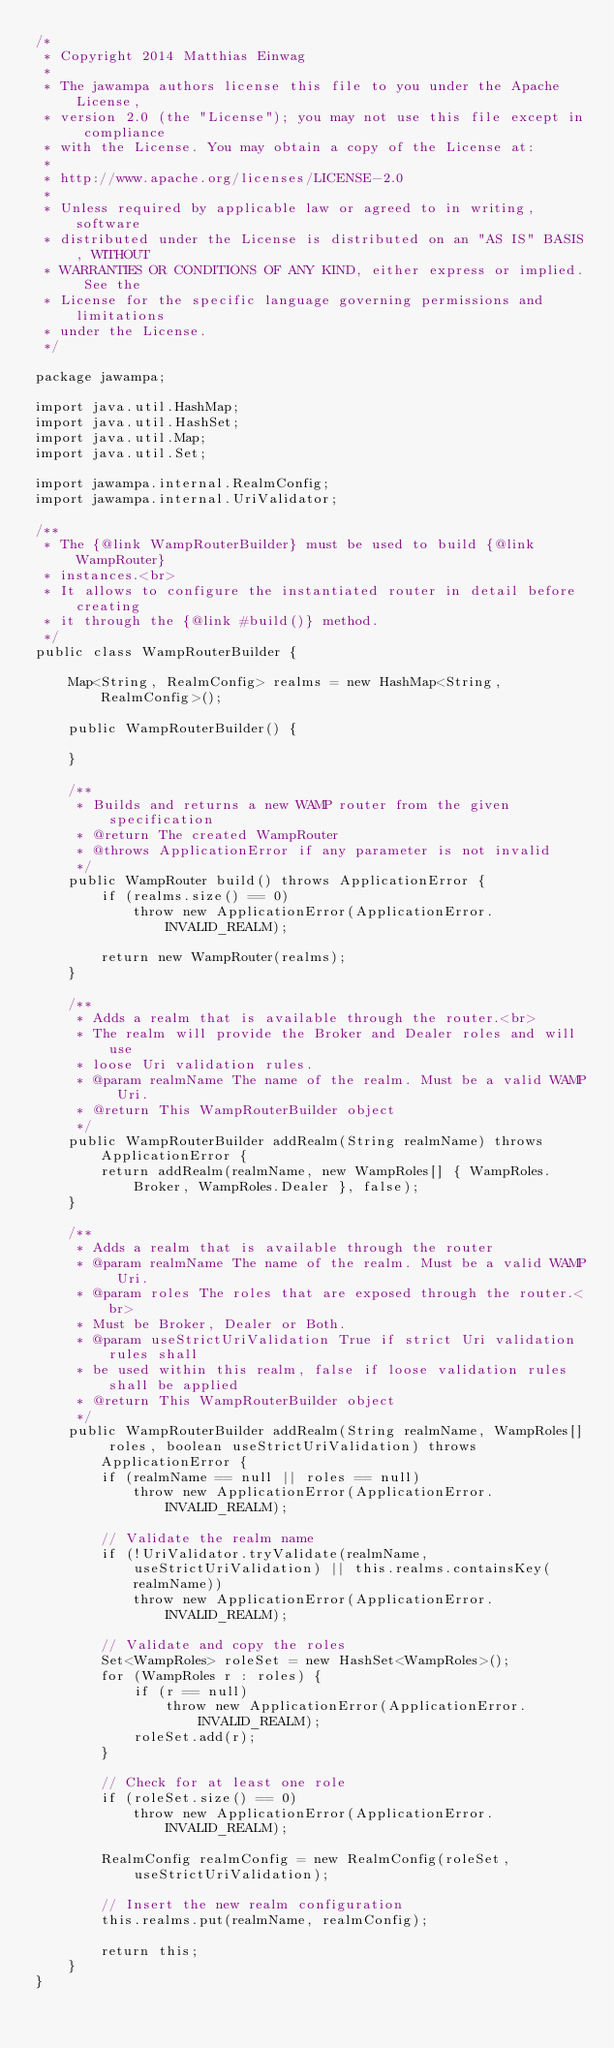<code> <loc_0><loc_0><loc_500><loc_500><_Java_>/*
 * Copyright 2014 Matthias Einwag
 *
 * The jawampa authors license this file to you under the Apache License,
 * version 2.0 (the "License"); you may not use this file except in compliance
 * with the License. You may obtain a copy of the License at:
 *
 * http://www.apache.org/licenses/LICENSE-2.0
 *
 * Unless required by applicable law or agreed to in writing, software
 * distributed under the License is distributed on an "AS IS" BASIS, WITHOUT
 * WARRANTIES OR CONDITIONS OF ANY KIND, either express or implied. See the
 * License for the specific language governing permissions and limitations
 * under the License.
 */

package jawampa;

import java.util.HashMap;
import java.util.HashSet;
import java.util.Map;
import java.util.Set;

import jawampa.internal.RealmConfig;
import jawampa.internal.UriValidator;

/**
 * The {@link WampRouterBuilder} must be used to build {@link WampRouter}
 * instances.<br>
 * It allows to configure the instantiated router in detail before creating
 * it through the {@link #build()} method.
 */
public class WampRouterBuilder {
    
    Map<String, RealmConfig> realms = new HashMap<String, RealmConfig>();

    public WampRouterBuilder() {
        
    }
    
    /**
     * Builds and returns a new WAMP router from the given specification
     * @return The created WampRouter
     * @throws ApplicationError if any parameter is not invalid
     */
    public WampRouter build() throws ApplicationError {
        if (realms.size() == 0)
            throw new ApplicationError(ApplicationError.INVALID_REALM);
        
        return new WampRouter(realms);
    }
    
    /**
     * Adds a realm that is available through the router.<br>
     * The realm will provide the Broker and Dealer roles and will use
     * loose Uri validation rules.
     * @param realmName The name of the realm. Must be a valid WAMP Uri.
     * @return This WampRouterBuilder object
     */
    public WampRouterBuilder addRealm(String realmName) throws ApplicationError {
        return addRealm(realmName, new WampRoles[] { WampRoles.Broker, WampRoles.Dealer }, false);
    }
    
    /**
     * Adds a realm that is available through the router
     * @param realmName The name of the realm. Must be a valid WAMP Uri.
     * @param roles The roles that are exposed through the router.<br>
     * Must be Broker, Dealer or Both.
     * @param useStrictUriValidation True if strict Uri validation rules shall
     * be used within this realm, false if loose validation rules shall be applied 
     * @return This WampRouterBuilder object
     */
    public WampRouterBuilder addRealm(String realmName, WampRoles[] roles, boolean useStrictUriValidation) throws ApplicationError {
        if (realmName == null || roles == null)
            throw new ApplicationError(ApplicationError.INVALID_REALM);
        
        // Validate the realm name
        if (!UriValidator.tryValidate(realmName, useStrictUriValidation) || this.realms.containsKey(realmName))
            throw new ApplicationError(ApplicationError.INVALID_REALM);
        
        // Validate and copy the roles
        Set<WampRoles> roleSet = new HashSet<WampRoles>();
        for (WampRoles r : roles) {
            if (r == null)
                throw new ApplicationError(ApplicationError.INVALID_REALM);
            roleSet.add(r);
        }
        
        // Check for at least one role
        if (roleSet.size() == 0)
            throw new ApplicationError(ApplicationError.INVALID_REALM);
        
        RealmConfig realmConfig = new RealmConfig(roleSet, useStrictUriValidation);
        
        // Insert the new realm configuration
        this.realms.put(realmName, realmConfig);
        
        return this;
    }
}
</code> 